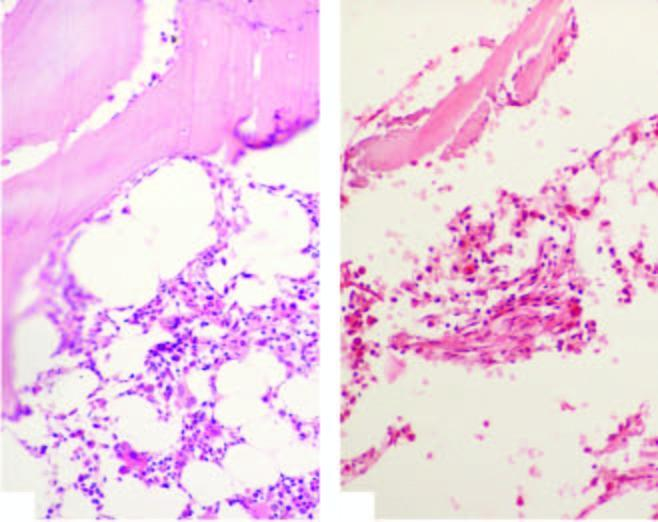what are there of cellular components composed chiefly of lymphoid cells?
Answer the question using a single word or phrase. Scanty foci 